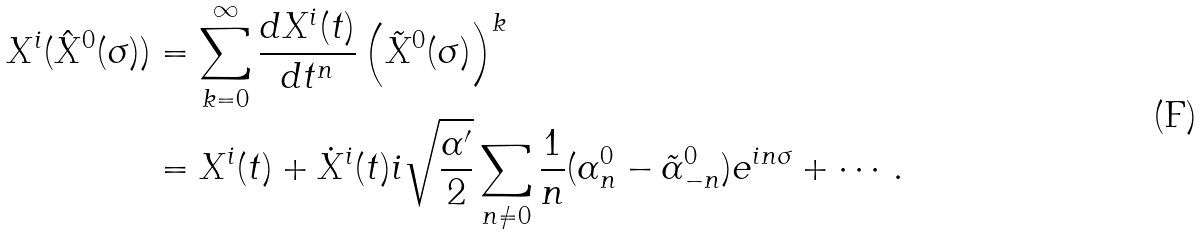<formula> <loc_0><loc_0><loc_500><loc_500>X ^ { i } ( \hat { X } ^ { 0 } ( \sigma ) ) & = \sum _ { k = 0 } ^ { \infty } \frac { d X ^ { i } ( t ) } { d t ^ { n } } \left ( \tilde { X } ^ { 0 } ( \sigma ) \right ) ^ { k } \\ & = X ^ { i } ( t ) + \dot { X } ^ { i } ( t ) i \sqrt { \frac { \alpha ^ { \prime } } { 2 } } \sum _ { n \ne 0 } \frac { 1 } { n } ( \alpha _ { n } ^ { 0 } - \tilde { \alpha } _ { - n } ^ { 0 } ) e ^ { i n \sigma } + \cdots .</formula> 